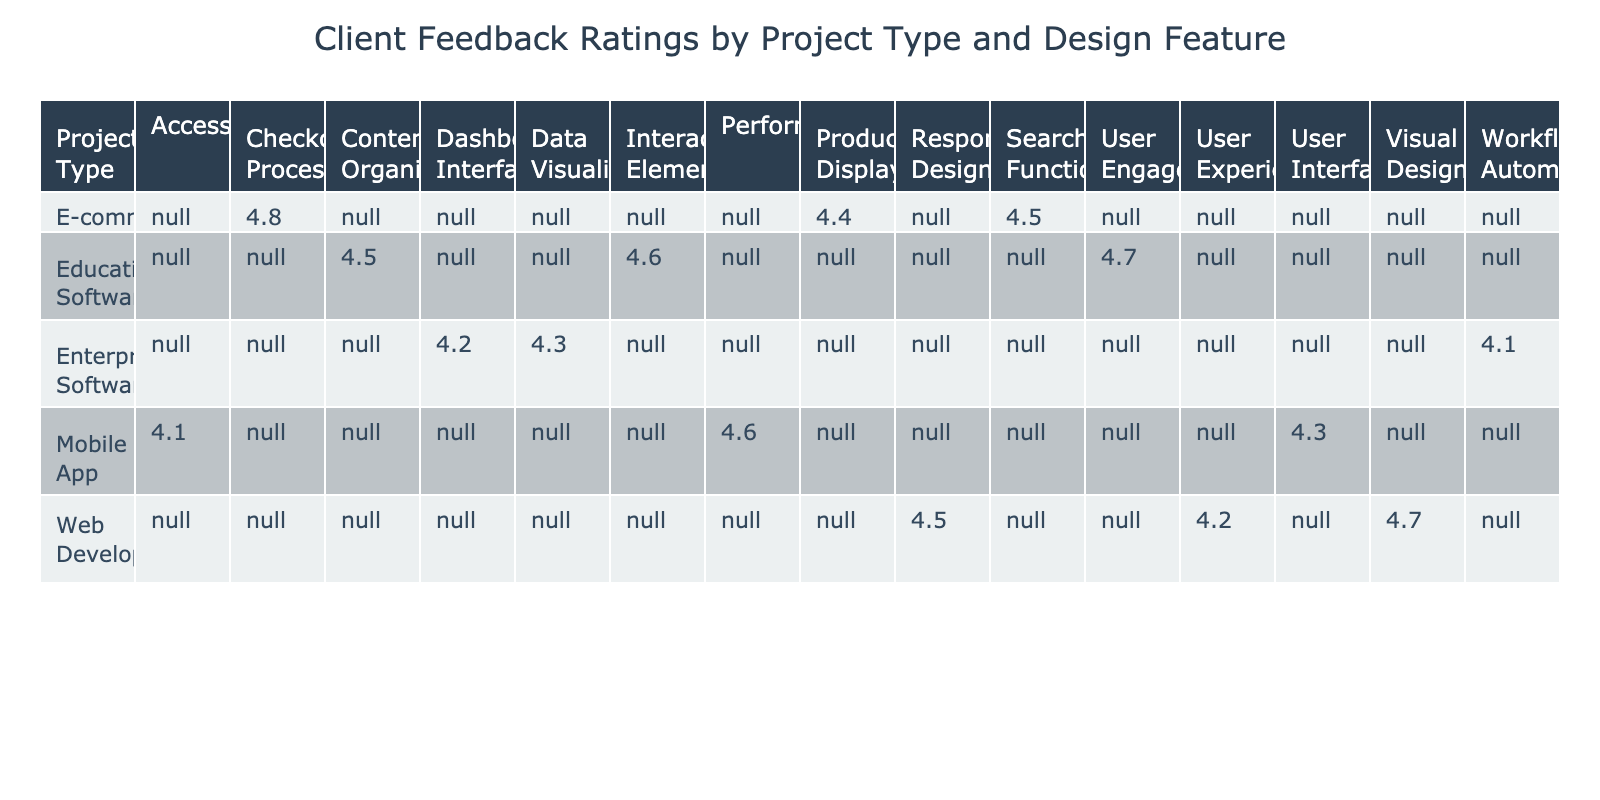What is the highest client feedback rating in the table? The table shows various feedback ratings for different design features across project types. By looking at the ratings provided, the highest rating can be found in the E-commerce project type for the Checkout Process, which has a rating of 4.8.
Answer: 4.8 Which project type received the lowest feedback rating for any design feature? The project type with the lowest feedback rating in the table is Enterprise Software. The lowest rating under this project type is for Workflow Automation, which has a rating of 4.1.
Answer: Enterprise Software What is the average client feedback rating for Mobile App design features? For Mobile App, the ratings are as follows: User Interface (4.3), Accessibility (4.1), and Performance (4.6). To find the average, we sum these ratings: 4.3 + 4.1 + 4.6 = 13.0, then divide by 3 (the number of features), giving us an average of 13.0 / 3 = 4.3.
Answer: 4.3 Is the feedback for Visual Design in Web Development higher than User Interface in Mobile App? The feedback rating for Visual Design in Web Development is 4.7, while the rating for User Interface in Mobile App is 4.3. Since 4.7 is greater than 4.3, this statement is true.
Answer: Yes What is the total feedback rating for all design features under E-commerce? The ratings for E-commerce are: Checkout Process (4.8), Product Display (4.4), and Search Functionality (4.5). Adding these ratings gives us a total of 4.8 + 4.4 + 4.5 = 13.7.
Answer: 13.7 Which design feature across all projects has the highest rating? By inspecting all ratings in the table, the Checkout Process under E-commerce has the highest rating of 4.8. This is the only instance of a rating at this level.
Answer: Checkout Process Did Educational Software receive a rating of 4.5 for any of its design features? Upon checking the Educational Software row, we find that Content Organization received a rating of exactly 4.5, confirming that this is true.
Answer: Yes How does the feedback for User Engagement in Educational Software compare with Performance in Mobile App? User Engagement in Educational Software has a rating of 4.7, while Performance in Mobile App has a rating of 4.6. Since 4.7 is greater than 4.6, User Engagement has a higher rating.
Answer: User Engagement is higher 